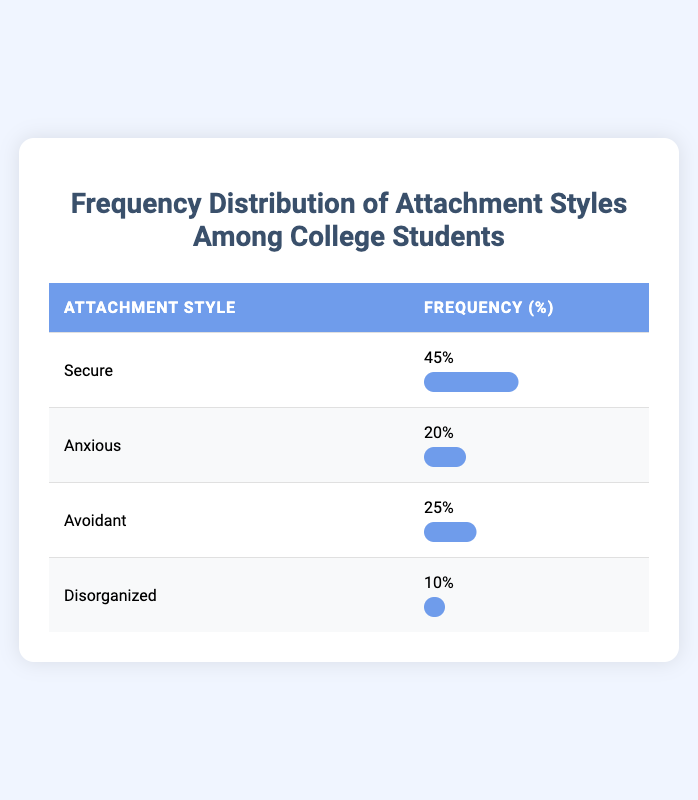What is the most common attachment style among college students? Looking at the table, "Secure" has the highest frequency at 45%. Therefore, it is the most common attachment style.
Answer: Secure How many students have an "Anxious" attachment style? The frequency of students with an "Anxious" attachment style is listed as 20 in the table.
Answer: 20 What percentage of students exhibit either "Avoidant" or "Disorganized" attachment styles combined? Adding the frequencies of "Avoidant" (25%) and "Disorganized" (10%) gives a total of 35%. Therefore, 35% of students exhibit either of these two attachment styles.
Answer: 35% Is it true that fewer students have a "Disorganized" attachment style than an "Anxious" one? The table shows "Disorganized" has a frequency of 10%, while "Anxious" has 20%. Thus, it is true that fewer students have a "Disorganized" attachment style.
Answer: Yes What is the difference in frequency between "Secure" and "Disorganized" attachment styles? The frequency of "Secure" is 45%, and "Disorganized" is 10%. The difference is calculated as 45% - 10% = 35%.
Answer: 35% 